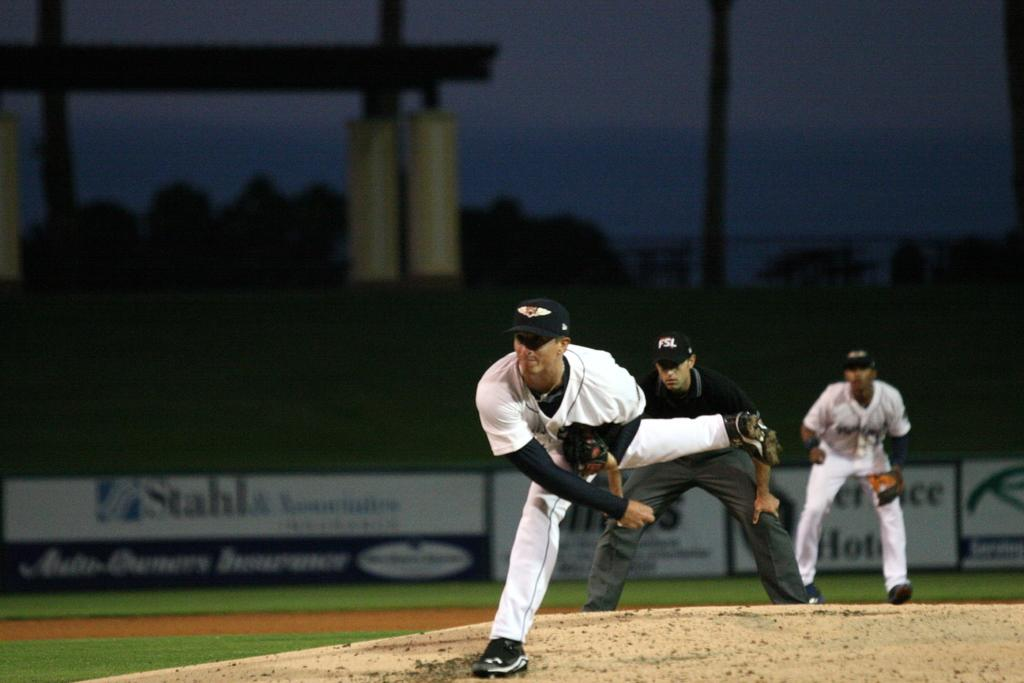What is the main subject of the image? The main subject of the image is men standing. Where are the men standing in the image? The men are standing on the ground. What can be seen in the background of the image? In the background of the image, there are trees, advertisement boards, poles, and the sky. How does the water move in the image? There is no water present in the image. What do the men wish for in the image? There is no indication of the men's wishes in the image. 